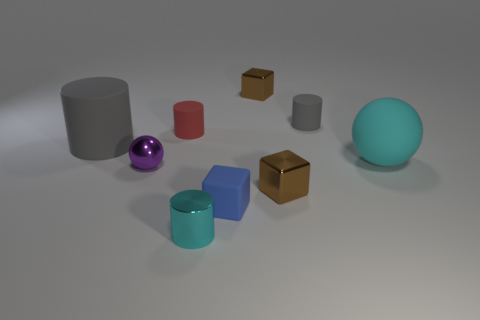Subtract all rubber cylinders. How many cylinders are left? 1 Subtract all green cylinders. How many brown blocks are left? 2 Add 1 cyan shiny cylinders. How many objects exist? 10 Subtract all cyan balls. How many balls are left? 1 Subtract 1 cylinders. How many cylinders are left? 3 Subtract all blocks. How many objects are left? 6 Add 9 small gray cylinders. How many small gray cylinders are left? 10 Add 2 cylinders. How many cylinders exist? 6 Subtract 0 gray cubes. How many objects are left? 9 Subtract all purple cubes. Subtract all brown cylinders. How many cubes are left? 3 